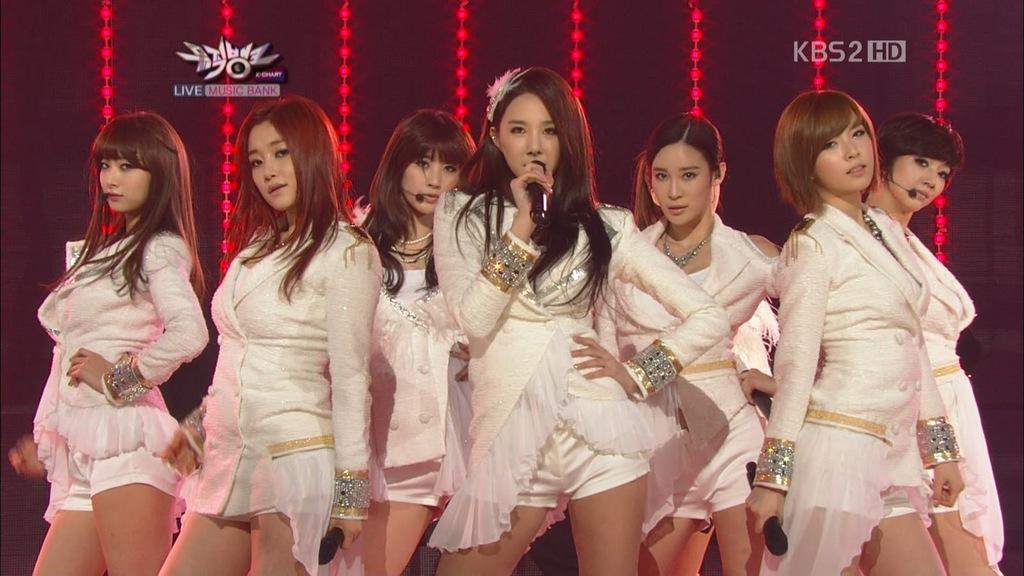What can be seen in the image? There are women standing in the image. What are the women wearing? The women are wearing white dresses. What are the women holding in their hands? The women are holding microphones. What can be seen hanging at the back of the scene? Lights are hanging at the back of the scene. Where is the desk located in the image? There is no desk present in the image. What type of church can be seen in the background of the image? There is no church visible in the image; it features women standing with microphones and lights hanging at the back of the scene. 